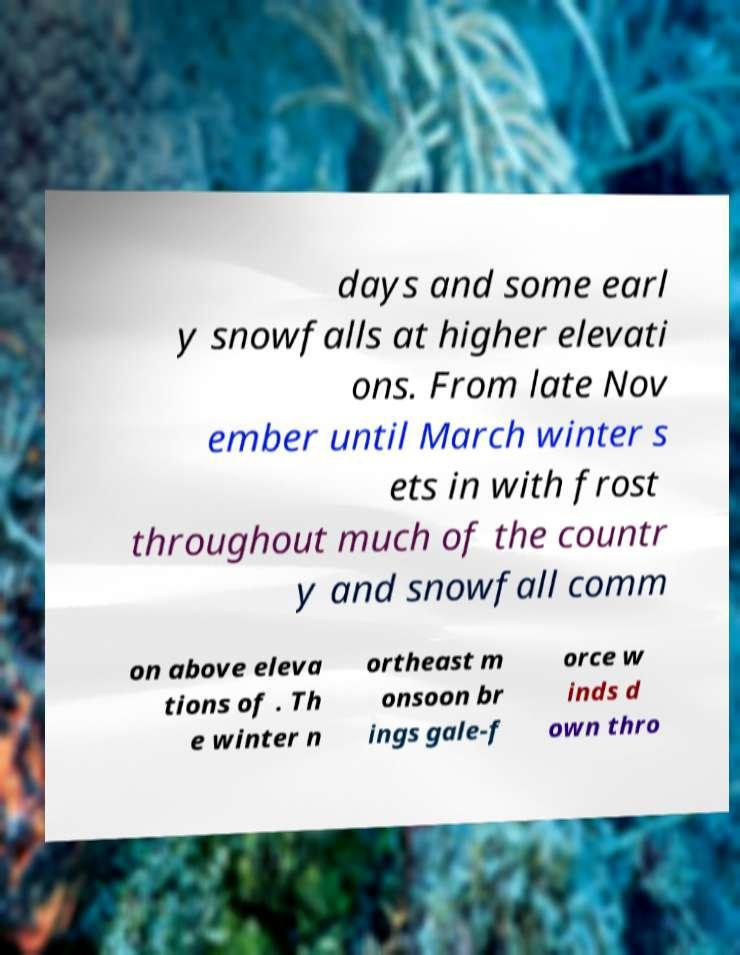Can you accurately transcribe the text from the provided image for me? days and some earl y snowfalls at higher elevati ons. From late Nov ember until March winter s ets in with frost throughout much of the countr y and snowfall comm on above eleva tions of . Th e winter n ortheast m onsoon br ings gale-f orce w inds d own thro 